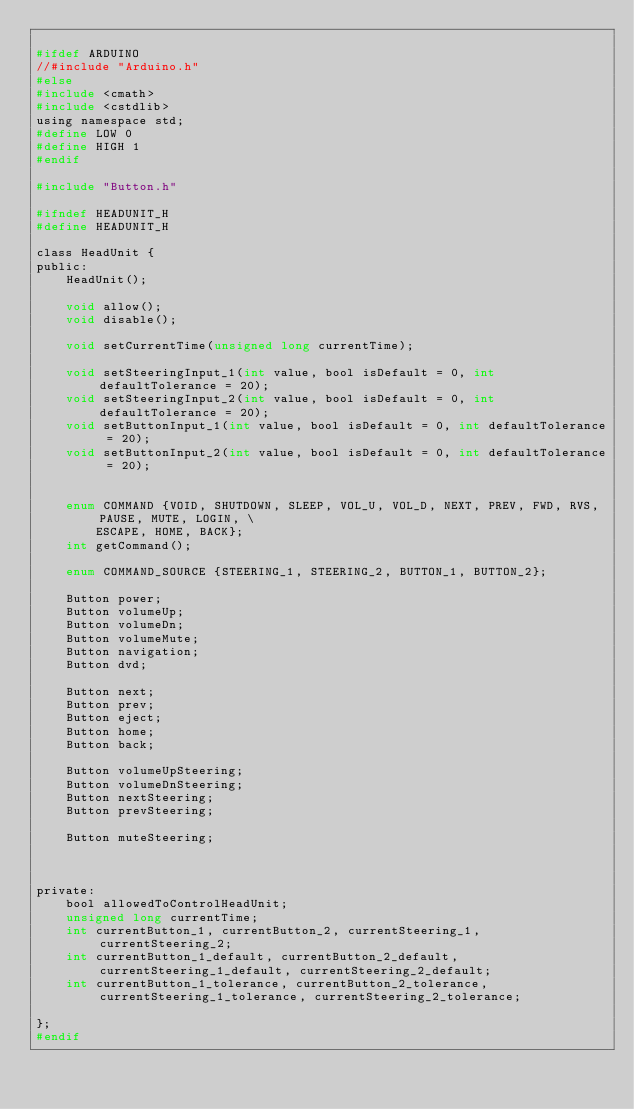<code> <loc_0><loc_0><loc_500><loc_500><_C_>
#ifdef ARDUINO
//#include "Arduino.h"
#else
#include <cmath>
#include <cstdlib>
using namespace std;
#define LOW 0
#define HIGH 1
#endif

#include "Button.h"

#ifndef HEADUNIT_H
#define HEADUNIT_H

class HeadUnit {
public:
    HeadUnit();
    
    void allow();
    void disable();
    
    void setCurrentTime(unsigned long currentTime);
    
    void setSteeringInput_1(int value, bool isDefault = 0, int defaultTolerance = 20);
    void setSteeringInput_2(int value, bool isDefault = 0, int defaultTolerance = 20);
    void setButtonInput_1(int value, bool isDefault = 0, int defaultTolerance = 20);
    void setButtonInput_2(int value, bool isDefault = 0, int defaultTolerance = 20);
    
    
    enum COMMAND {VOID, SHUTDOWN, SLEEP, VOL_U, VOL_D, NEXT, PREV, FWD, RVS, PAUSE, MUTE, LOGIN, \
        ESCAPE, HOME, BACK};
    int getCommand();
    
    enum COMMAND_SOURCE {STEERING_1, STEERING_2, BUTTON_1, BUTTON_2};
    
    Button power;
    Button volumeUp;
    Button volumeDn;
    Button volumeMute;
    Button navigation;
    Button dvd;
    
    Button next;
    Button prev;
    Button eject;
    Button home;
    Button back;
    
    Button volumeUpSteering;
    Button volumeDnSteering;
    Button nextSteering;
    Button prevSteering;
    
    Button muteSteering;
    
    
    
private:
    bool allowedToControlHeadUnit;
    unsigned long currentTime;
    int currentButton_1, currentButton_2, currentSteering_1, currentSteering_2;
    int currentButton_1_default, currentButton_2_default, currentSteering_1_default, currentSteering_2_default;
    int currentButton_1_tolerance, currentButton_2_tolerance, currentSteering_1_tolerance, currentSteering_2_tolerance;
    
};
#endif
</code> 